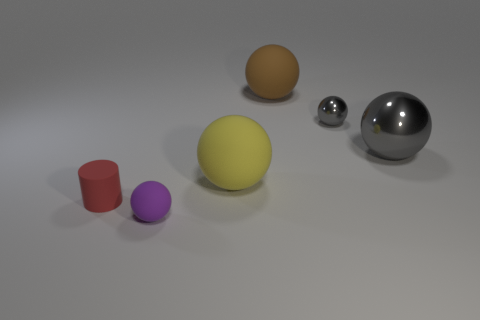What might be the purpose of this arrangement? This arrangement could serve several purposes. It might be a visualization created to study the effects of light on different surfaces and colors, an aesthetic composition for a graphic design project, or simply a digital 3D rendering practice to showcase the creator's ability to model and render different shapes and materials. 